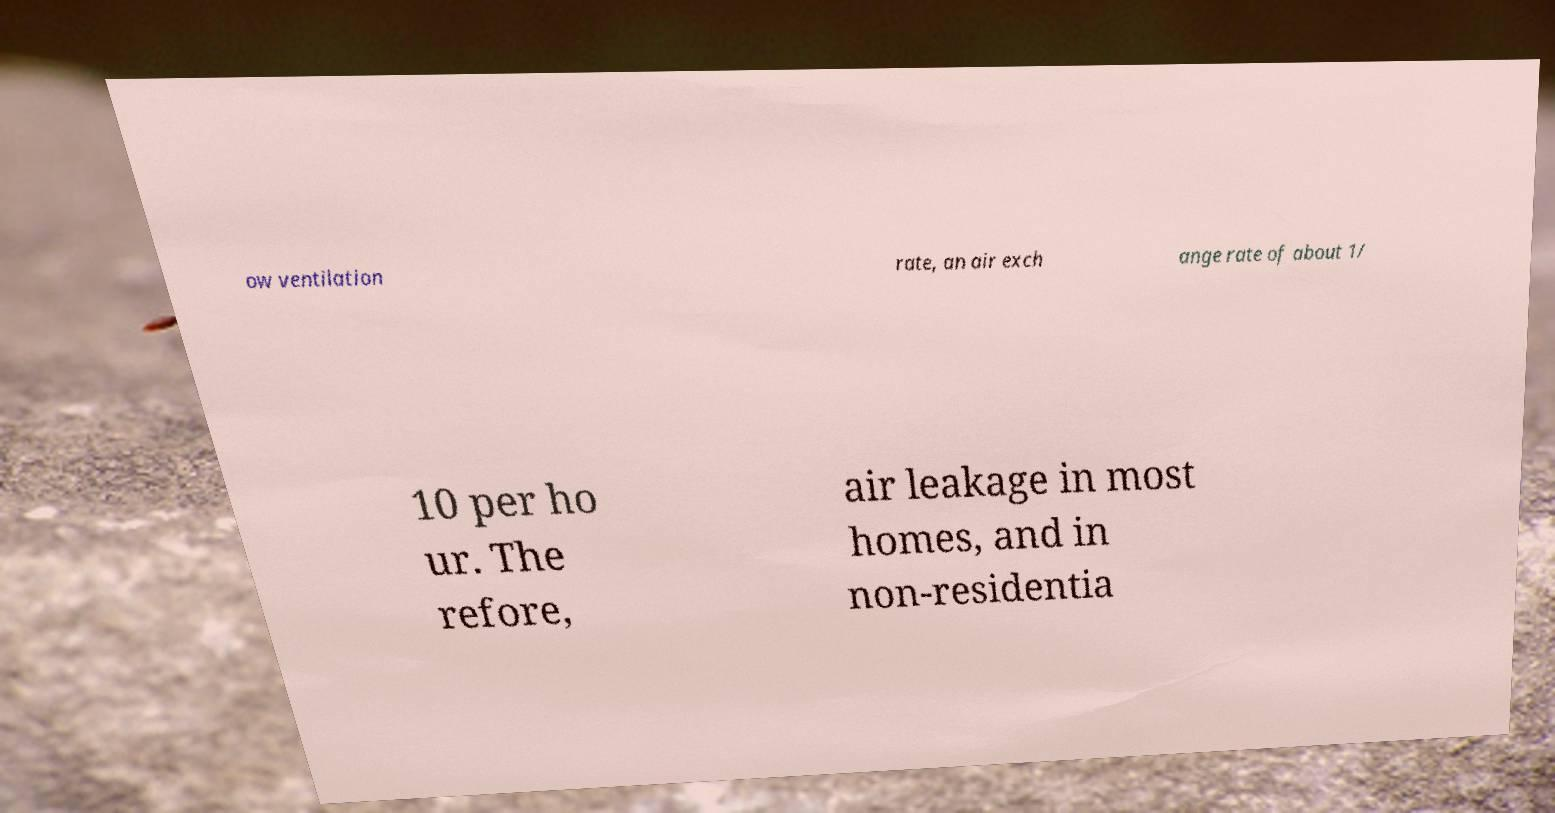Could you assist in decoding the text presented in this image and type it out clearly? ow ventilation rate, an air exch ange rate of about 1/ 10 per ho ur. The refore, air leakage in most homes, and in non-residentia 